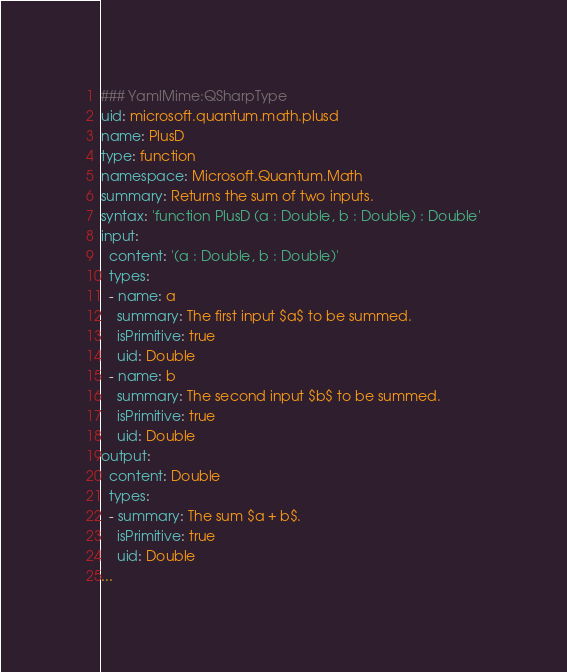<code> <loc_0><loc_0><loc_500><loc_500><_YAML_>### YamlMime:QSharpType
uid: microsoft.quantum.math.plusd
name: PlusD
type: function
namespace: Microsoft.Quantum.Math
summary: Returns the sum of two inputs.
syntax: 'function PlusD (a : Double, b : Double) : Double'
input:
  content: '(a : Double, b : Double)'
  types:
  - name: a
    summary: The first input $a$ to be summed.
    isPrimitive: true
    uid: Double
  - name: b
    summary: The second input $b$ to be summed.
    isPrimitive: true
    uid: Double
output:
  content: Double
  types:
  - summary: The sum $a + b$.
    isPrimitive: true
    uid: Double
...
</code> 